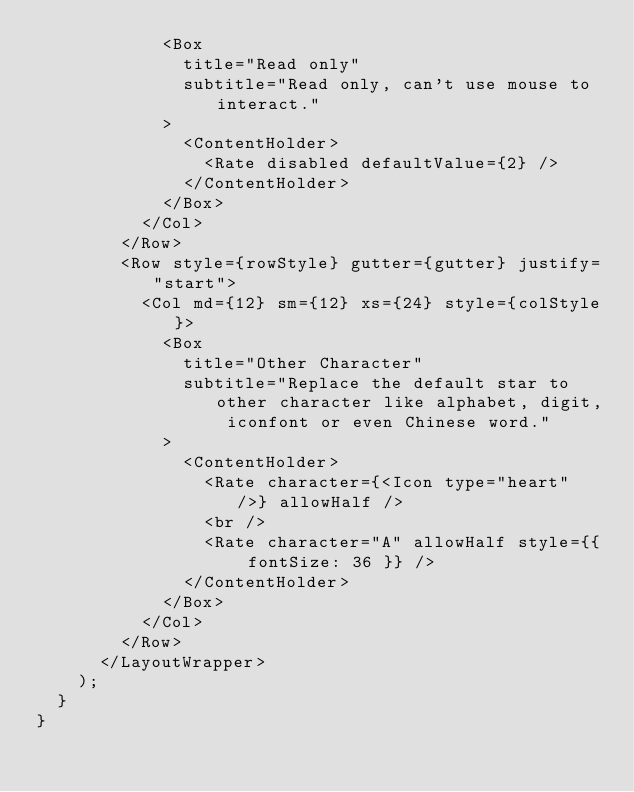<code> <loc_0><loc_0><loc_500><loc_500><_JavaScript_>            <Box
              title="Read only"
              subtitle="Read only, can't use mouse to interact."
            >
              <ContentHolder>
                <Rate disabled defaultValue={2} />
              </ContentHolder>
            </Box>
          </Col>
        </Row>
        <Row style={rowStyle} gutter={gutter} justify="start">
          <Col md={12} sm={12} xs={24} style={colStyle}>
            <Box
              title="Other Character"
              subtitle="Replace the default star to other character like alphabet, digit, iconfont or even Chinese word."
            >
              <ContentHolder>
                <Rate character={<Icon type="heart" />} allowHalf />
                <br />
                <Rate character="A" allowHalf style={{ fontSize: 36 }} />
              </ContentHolder>
            </Box>
          </Col>
        </Row>
      </LayoutWrapper>
    );
  }
}
</code> 